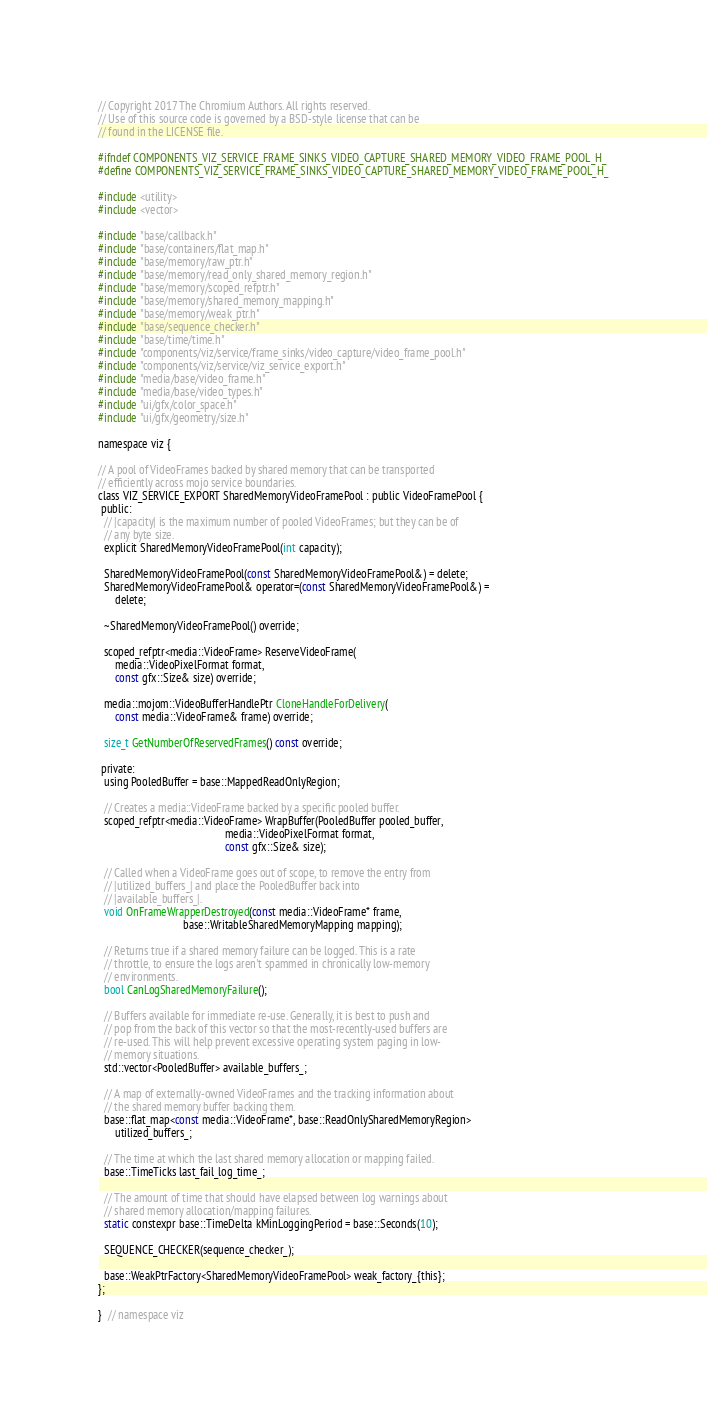<code> <loc_0><loc_0><loc_500><loc_500><_C_>// Copyright 2017 The Chromium Authors. All rights reserved.
// Use of this source code is governed by a BSD-style license that can be
// found in the LICENSE file.

#ifndef COMPONENTS_VIZ_SERVICE_FRAME_SINKS_VIDEO_CAPTURE_SHARED_MEMORY_VIDEO_FRAME_POOL_H_
#define COMPONENTS_VIZ_SERVICE_FRAME_SINKS_VIDEO_CAPTURE_SHARED_MEMORY_VIDEO_FRAME_POOL_H_

#include <utility>
#include <vector>

#include "base/callback.h"
#include "base/containers/flat_map.h"
#include "base/memory/raw_ptr.h"
#include "base/memory/read_only_shared_memory_region.h"
#include "base/memory/scoped_refptr.h"
#include "base/memory/shared_memory_mapping.h"
#include "base/memory/weak_ptr.h"
#include "base/sequence_checker.h"
#include "base/time/time.h"
#include "components/viz/service/frame_sinks/video_capture/video_frame_pool.h"
#include "components/viz/service/viz_service_export.h"
#include "media/base/video_frame.h"
#include "media/base/video_types.h"
#include "ui/gfx/color_space.h"
#include "ui/gfx/geometry/size.h"

namespace viz {

// A pool of VideoFrames backed by shared memory that can be transported
// efficiently across mojo service boundaries.
class VIZ_SERVICE_EXPORT SharedMemoryVideoFramePool : public VideoFramePool {
 public:
  // |capacity| is the maximum number of pooled VideoFrames; but they can be of
  // any byte size.
  explicit SharedMemoryVideoFramePool(int capacity);

  SharedMemoryVideoFramePool(const SharedMemoryVideoFramePool&) = delete;
  SharedMemoryVideoFramePool& operator=(const SharedMemoryVideoFramePool&) =
      delete;

  ~SharedMemoryVideoFramePool() override;

  scoped_refptr<media::VideoFrame> ReserveVideoFrame(
      media::VideoPixelFormat format,
      const gfx::Size& size) override;

  media::mojom::VideoBufferHandlePtr CloneHandleForDelivery(
      const media::VideoFrame& frame) override;

  size_t GetNumberOfReservedFrames() const override;

 private:
  using PooledBuffer = base::MappedReadOnlyRegion;

  // Creates a media::VideoFrame backed by a specific pooled buffer.
  scoped_refptr<media::VideoFrame> WrapBuffer(PooledBuffer pooled_buffer,
                                              media::VideoPixelFormat format,
                                              const gfx::Size& size);

  // Called when a VideoFrame goes out of scope, to remove the entry from
  // |utilized_buffers_| and place the PooledBuffer back into
  // |available_buffers_|.
  void OnFrameWrapperDestroyed(const media::VideoFrame* frame,
                               base::WritableSharedMemoryMapping mapping);

  // Returns true if a shared memory failure can be logged. This is a rate
  // throttle, to ensure the logs aren't spammed in chronically low-memory
  // environments.
  bool CanLogSharedMemoryFailure();

  // Buffers available for immediate re-use. Generally, it is best to push and
  // pop from the back of this vector so that the most-recently-used buffers are
  // re-used. This will help prevent excessive operating system paging in low-
  // memory situations.
  std::vector<PooledBuffer> available_buffers_;

  // A map of externally-owned VideoFrames and the tracking information about
  // the shared memory buffer backing them.
  base::flat_map<const media::VideoFrame*, base::ReadOnlySharedMemoryRegion>
      utilized_buffers_;

  // The time at which the last shared memory allocation or mapping failed.
  base::TimeTicks last_fail_log_time_;

  // The amount of time that should have elapsed between log warnings about
  // shared memory allocation/mapping failures.
  static constexpr base::TimeDelta kMinLoggingPeriod = base::Seconds(10);

  SEQUENCE_CHECKER(sequence_checker_);

  base::WeakPtrFactory<SharedMemoryVideoFramePool> weak_factory_{this};
};

}  // namespace viz
</code> 